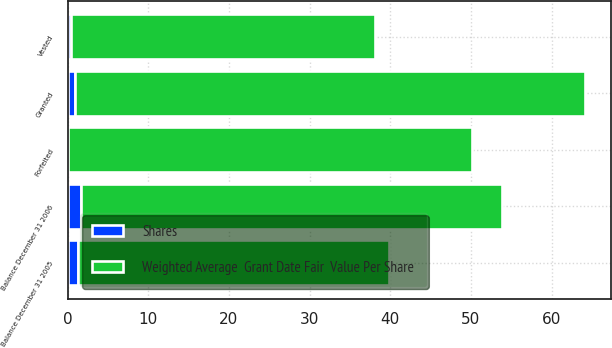Convert chart to OTSL. <chart><loc_0><loc_0><loc_500><loc_500><stacked_bar_chart><ecel><fcel>Balance December 31 2005<fcel>Granted<fcel>Vested<fcel>Forfeited<fcel>Balance December 31 2006<nl><fcel>Shares<fcel>1.3<fcel>0.9<fcel>0.4<fcel>0.1<fcel>1.7<nl><fcel>Weighted Average  Grant Date Fair  Value Per Share<fcel>38.59<fcel>63.31<fcel>37.76<fcel>50.03<fcel>52.12<nl></chart> 